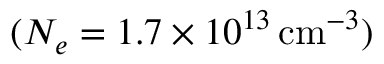Convert formula to latex. <formula><loc_0><loc_0><loc_500><loc_500>( N _ { e } = 1 . 7 \times 1 0 ^ { 1 3 } \, c m ^ { - 3 } )</formula> 